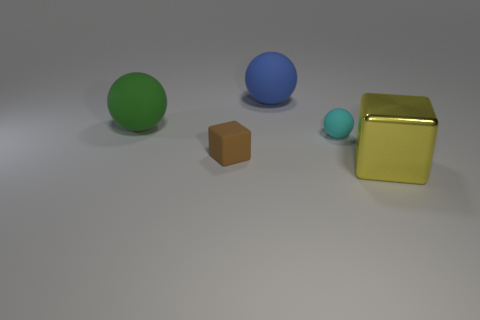Is the number of large objects right of the large blue sphere greater than the number of tiny matte things that are behind the small cyan matte ball?
Your response must be concise. Yes. How many large balls are to the right of the big green ball?
Offer a very short reply. 1. Do the blue thing and the block that is behind the big yellow metallic cube have the same material?
Keep it short and to the point. Yes. Is the material of the blue ball the same as the big yellow thing?
Offer a very short reply. No. Are there any big matte things behind the large rubber ball that is in front of the large blue thing?
Give a very brief answer. Yes. What number of things are both right of the blue rubber thing and behind the big yellow metal block?
Offer a very short reply. 1. There is a large thing that is in front of the green object; what is its shape?
Keep it short and to the point. Cube. What number of cubes are the same size as the yellow thing?
Your answer should be compact. 0. There is a large object that is behind the big yellow object and on the right side of the rubber cube; what material is it?
Provide a succinct answer. Rubber. Are there more large red cylinders than big green balls?
Your answer should be very brief. No. 